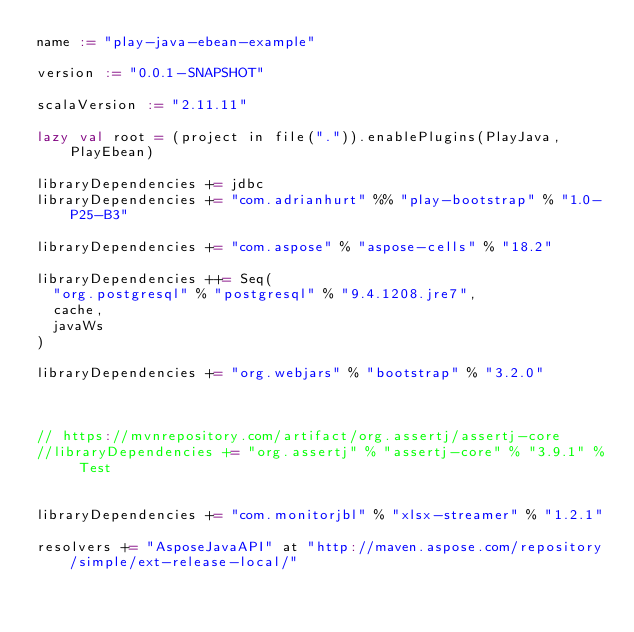<code> <loc_0><loc_0><loc_500><loc_500><_Scala_>name := "play-java-ebean-example"

version := "0.0.1-SNAPSHOT"

scalaVersion := "2.11.11"

lazy val root = (project in file(".")).enablePlugins(PlayJava, PlayEbean)
  
libraryDependencies += jdbc
libraryDependencies += "com.adrianhurt" %% "play-bootstrap" % "1.0-P25-B3"

libraryDependencies += "com.aspose" % "aspose-cells" % "18.2"

libraryDependencies ++= Seq(
  "org.postgresql" % "postgresql" % "9.4.1208.jre7",
  cache,
  javaWs
)

libraryDependencies += "org.webjars" % "bootstrap" % "3.2.0"



// https://mvnrepository.com/artifact/org.assertj/assertj-core
//libraryDependencies += "org.assertj" % "assertj-core" % "3.9.1" % Test


libraryDependencies += "com.monitorjbl" % "xlsx-streamer" % "1.2.1"

resolvers += "AsposeJavaAPI" at "http://maven.aspose.com/repository/simple/ext-release-local/"


</code> 